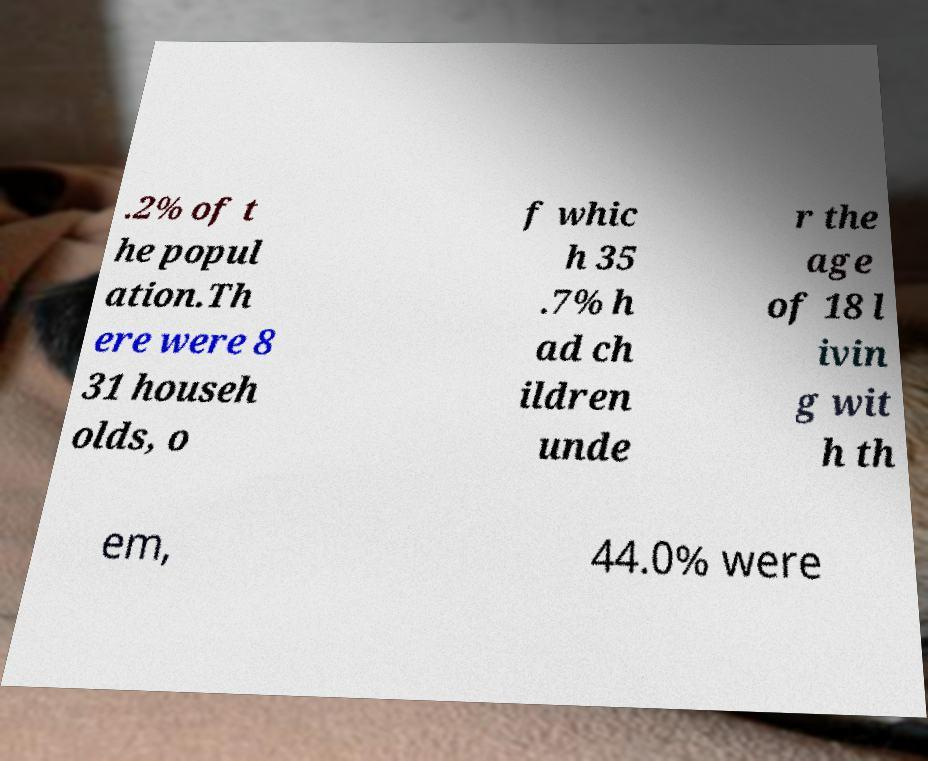Could you assist in decoding the text presented in this image and type it out clearly? .2% of t he popul ation.Th ere were 8 31 househ olds, o f whic h 35 .7% h ad ch ildren unde r the age of 18 l ivin g wit h th em, 44.0% were 